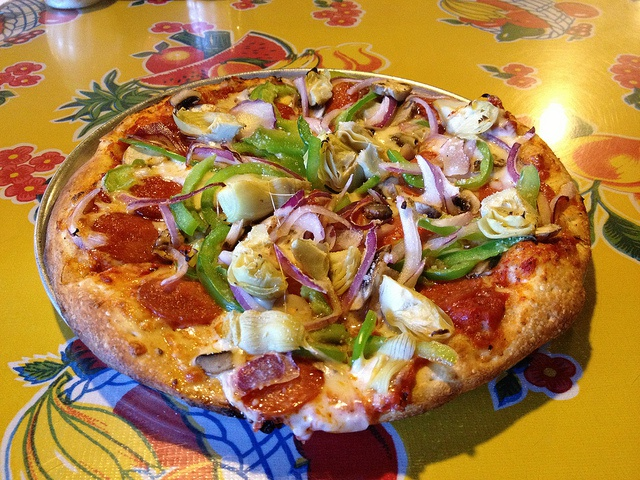Describe the objects in this image and their specific colors. I can see dining table in orange, tan, brown, maroon, and olive tones and pizza in lavender, brown, maroon, and tan tones in this image. 